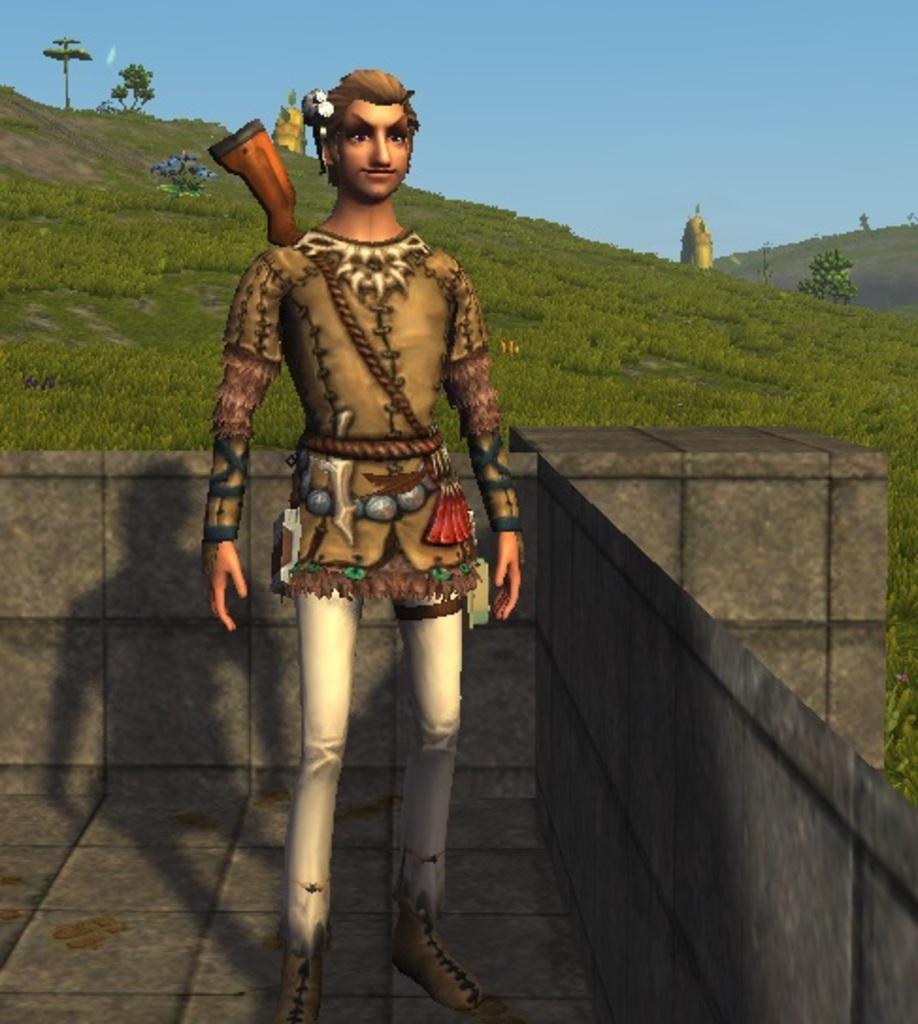Describe this image in one or two sentences. It is an animated image, in the middle a man is there. This is the grass, at the top it's a sky. 